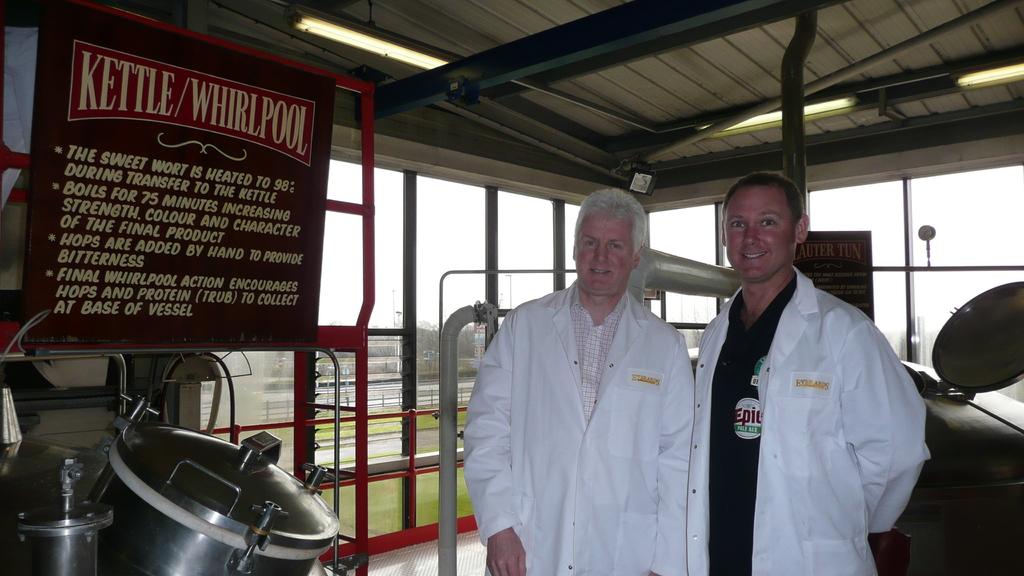What whirlpool is this?
Keep it short and to the point. Kettle. What is that gray thing?
Give a very brief answer. Kettle. 